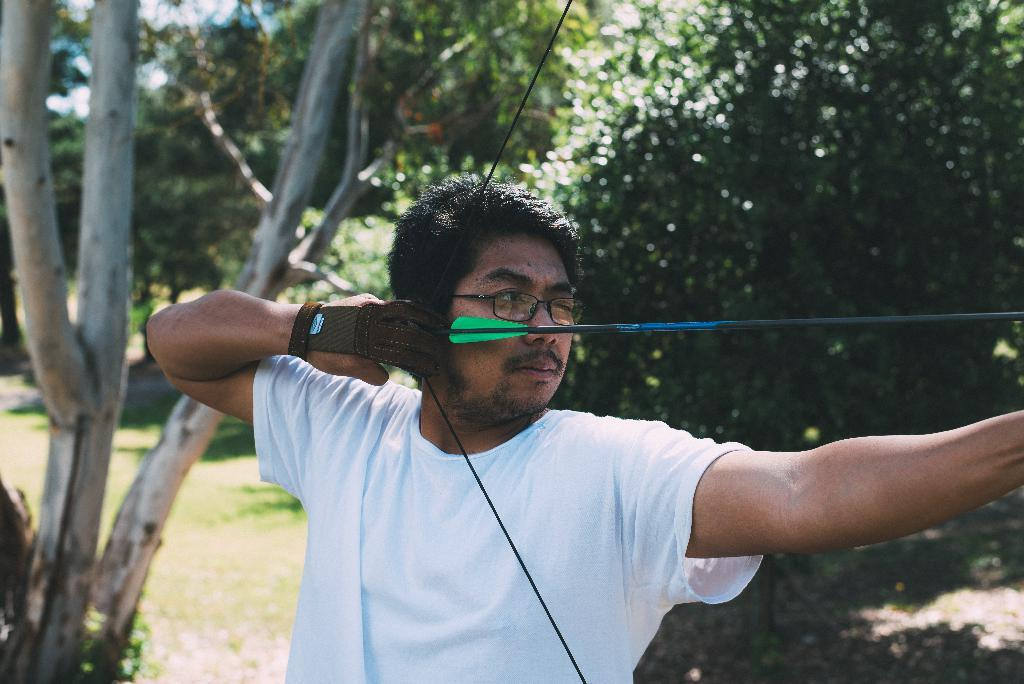What is the main subject of the image? There is a man in the image. What is the man doing in the image? The man is standing in the image. What objects is the man holding in the image? The man is holding a bow and an arrow in the image. What can be seen in the background of the image? There are trees in the background of the image. Where is the throne located in the image? There is no throne present in the image. What type of iron is the man using to shoot the arrow in the image? The man is not using any iron to shoot the arrow; he is using a bow. 